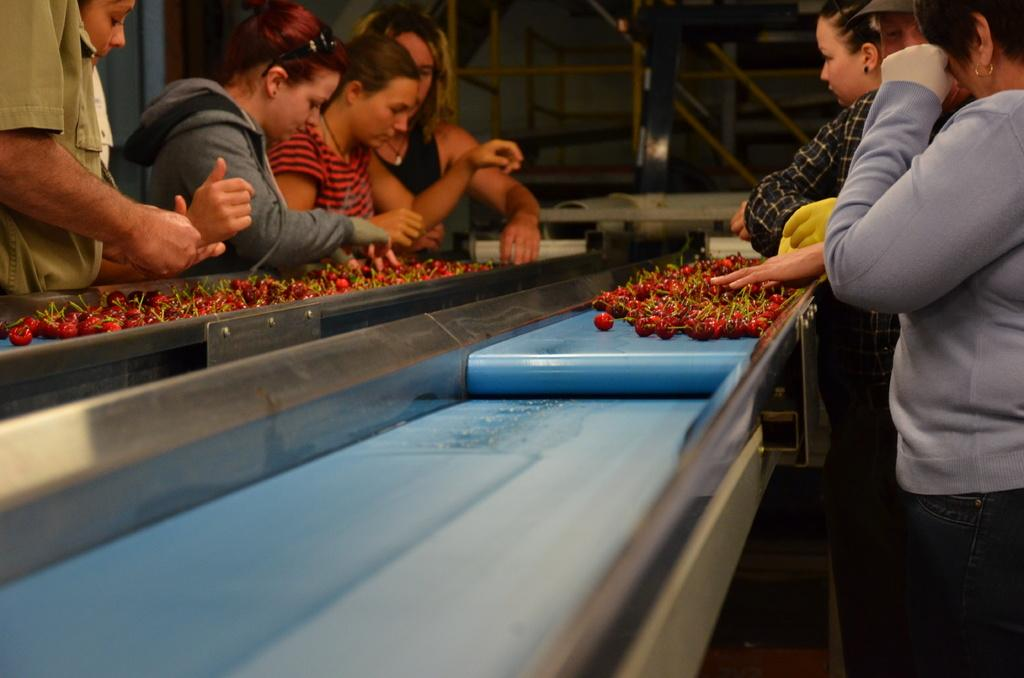What is being processed on the belt in the image? There are strawberries placed on a processing belt in the image. Can you describe the people in the image? There are people in the image, but their specific roles or actions are not mentioned in the provided facts. What can be seen in the background of the image? There are rods visible in the background of the image. What type of leaf is being used to commit a crime in the image? There is no leaf or crime present in the image; it features strawberries on a processing belt and people in the scene. 